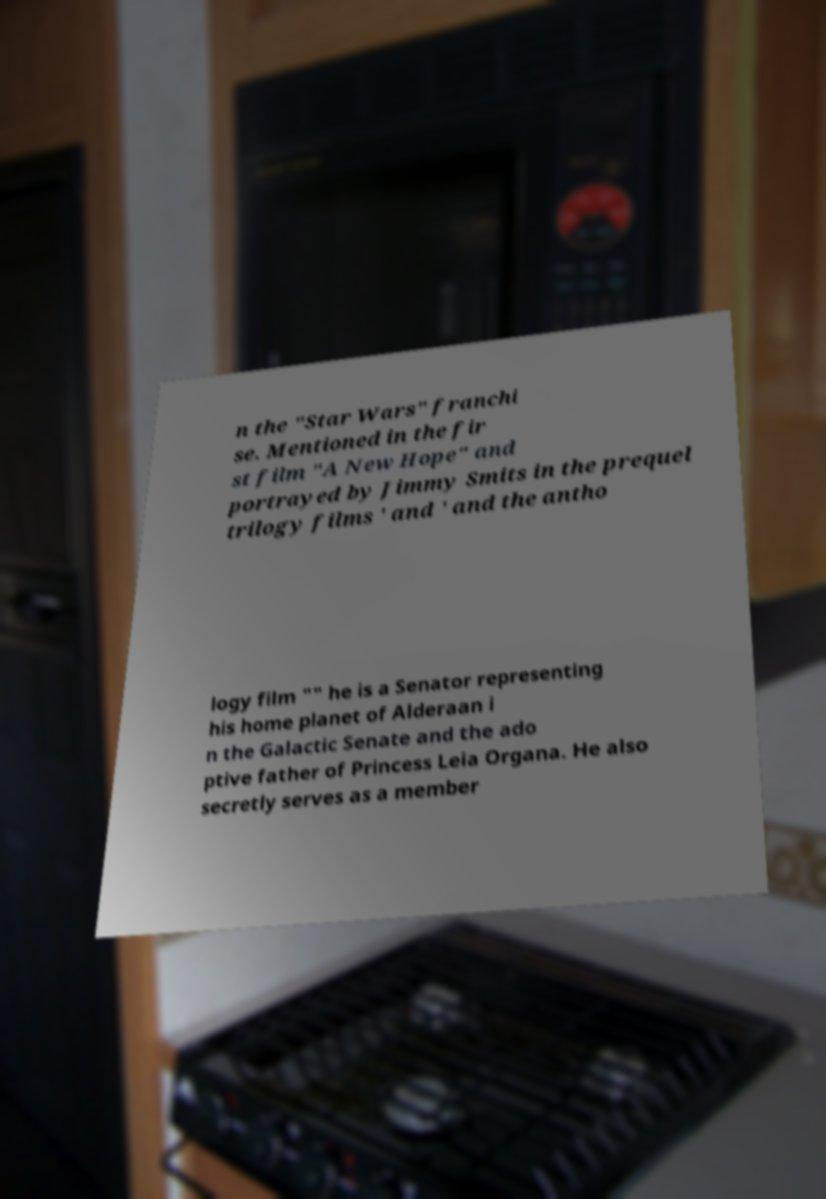What messages or text are displayed in this image? I need them in a readable, typed format. n the "Star Wars" franchi se. Mentioned in the fir st film "A New Hope" and portrayed by Jimmy Smits in the prequel trilogy films ' and ' and the antho logy film "" he is a Senator representing his home planet of Alderaan i n the Galactic Senate and the ado ptive father of Princess Leia Organa. He also secretly serves as a member 